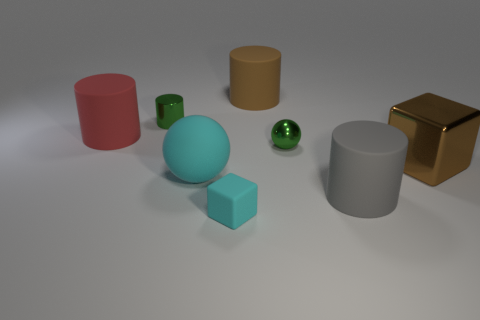Add 1 tiny green shiny cylinders. How many objects exist? 9 Subtract all spheres. How many objects are left? 6 Subtract all small shiny objects. Subtract all big brown blocks. How many objects are left? 5 Add 1 tiny rubber things. How many tiny rubber things are left? 2 Add 1 small green balls. How many small green balls exist? 2 Subtract 0 gray spheres. How many objects are left? 8 